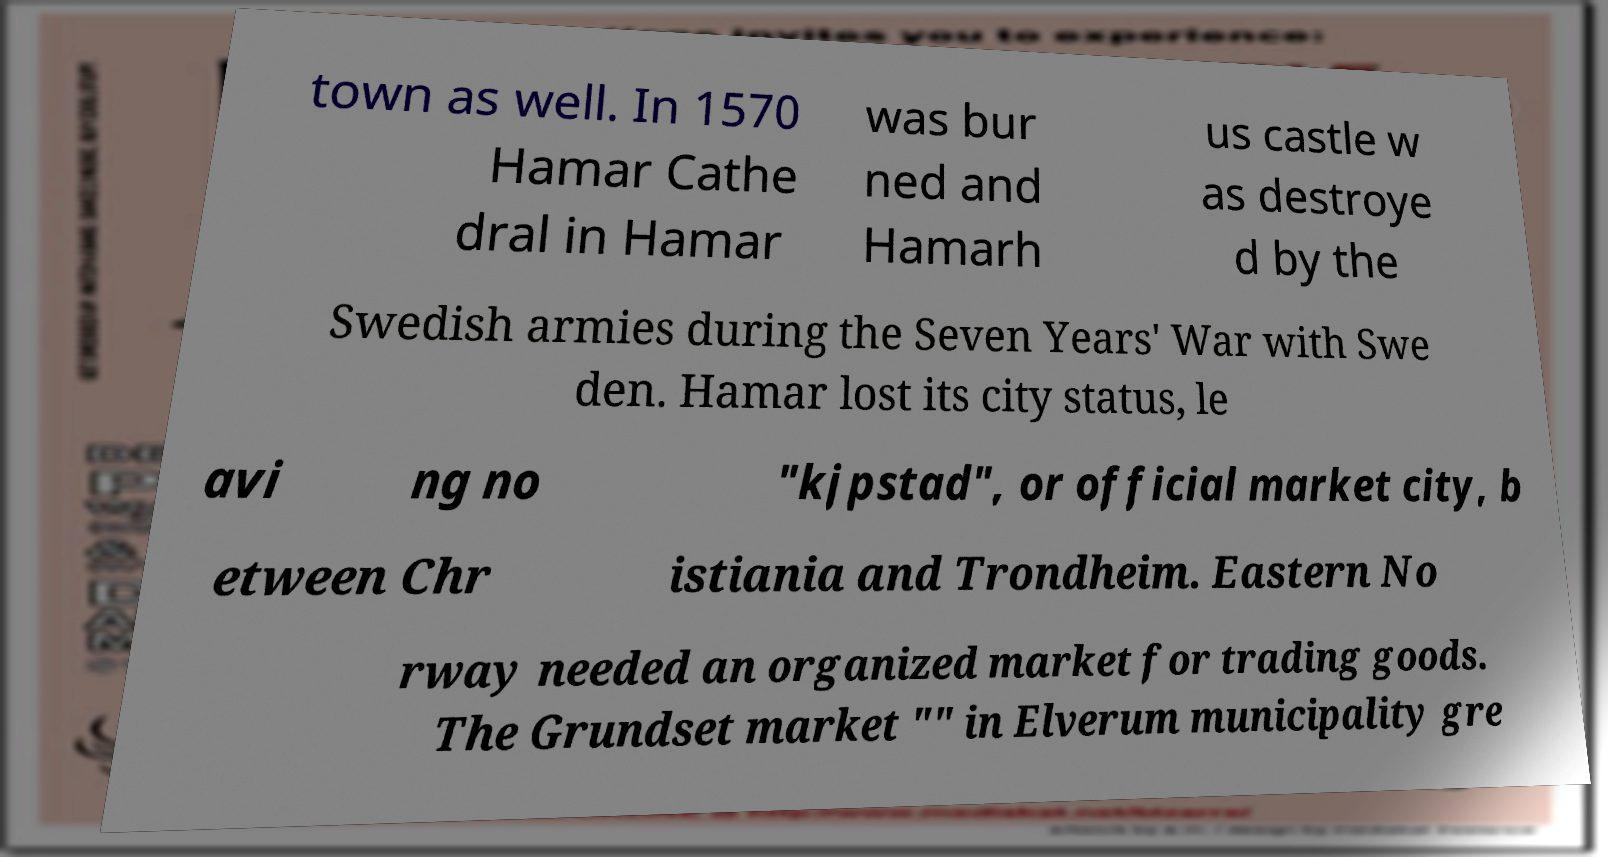Please identify and transcribe the text found in this image. town as well. In 1570 Hamar Cathe dral in Hamar was bur ned and Hamarh us castle w as destroye d by the Swedish armies during the Seven Years' War with Swe den. Hamar lost its city status, le avi ng no "kjpstad", or official market city, b etween Chr istiania and Trondheim. Eastern No rway needed an organized market for trading goods. The Grundset market "" in Elverum municipality gre 